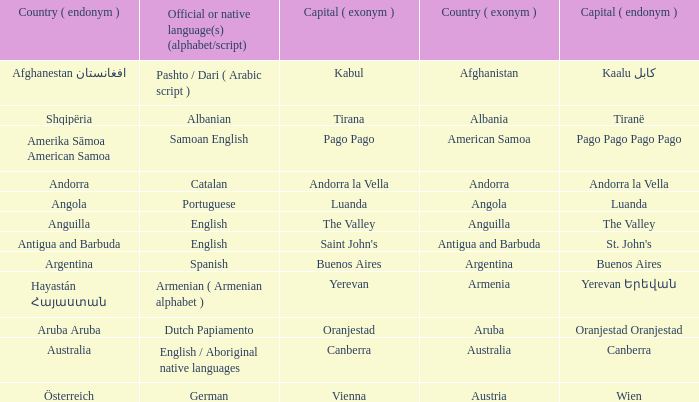What is the local name given to the city of Canberra? Canberra. 